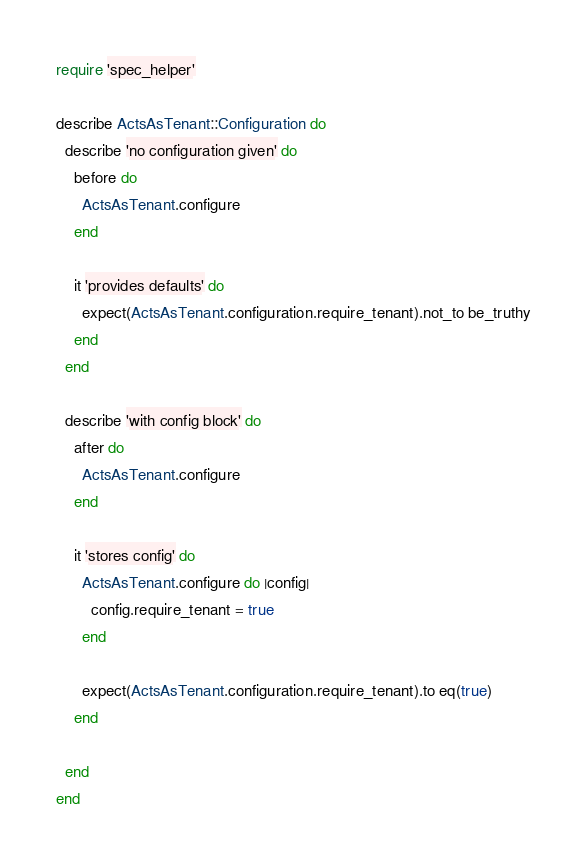<code> <loc_0><loc_0><loc_500><loc_500><_Ruby_>require 'spec_helper'

describe ActsAsTenant::Configuration do
  describe 'no configuration given' do
    before do
      ActsAsTenant.configure
    end

    it 'provides defaults' do
      expect(ActsAsTenant.configuration.require_tenant).not_to be_truthy
    end
  end

  describe 'with config block' do
    after do
      ActsAsTenant.configure
    end

    it 'stores config' do
      ActsAsTenant.configure do |config|
        config.require_tenant = true
      end

      expect(ActsAsTenant.configuration.require_tenant).to eq(true)
    end

  end
end
</code> 